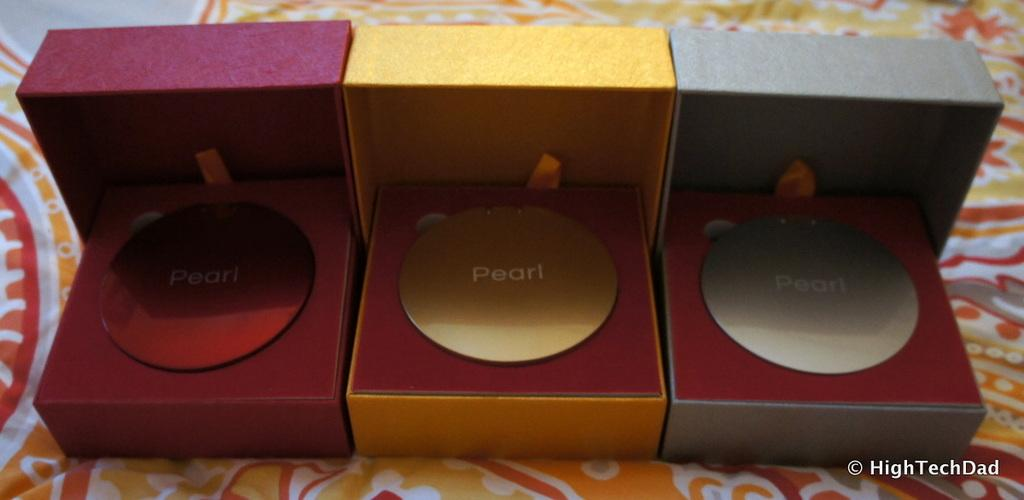<image>
Provide a brief description of the given image. Three different colored boxes with a circular disk inside that says Pearl. 